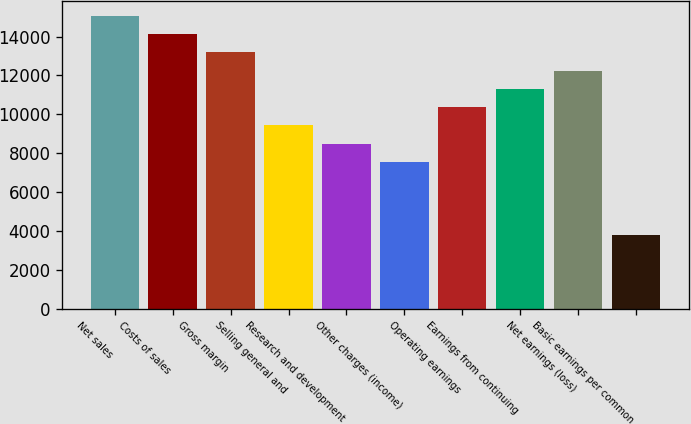Convert chart. <chart><loc_0><loc_0><loc_500><loc_500><bar_chart><fcel>Net sales<fcel>Costs of sales<fcel>Gross margin<fcel>Selling general and<fcel>Research and development<fcel>Other charges (income)<fcel>Operating earnings<fcel>Earnings from continuing<fcel>Net earnings (loss)<fcel>Basic earnings per common<nl><fcel>15078.4<fcel>14136<fcel>13193.6<fcel>9424.04<fcel>8481.64<fcel>7539.24<fcel>10366.4<fcel>11308.8<fcel>12251.2<fcel>3769.64<nl></chart> 